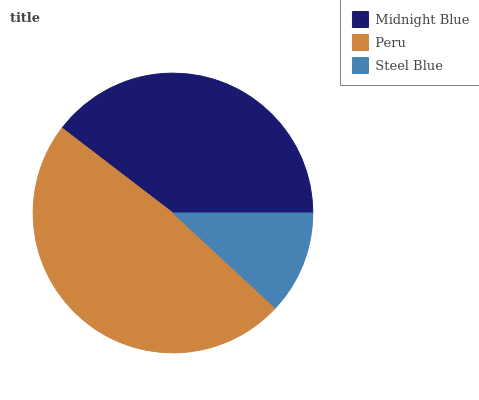Is Steel Blue the minimum?
Answer yes or no. Yes. Is Peru the maximum?
Answer yes or no. Yes. Is Peru the minimum?
Answer yes or no. No. Is Steel Blue the maximum?
Answer yes or no. No. Is Peru greater than Steel Blue?
Answer yes or no. Yes. Is Steel Blue less than Peru?
Answer yes or no. Yes. Is Steel Blue greater than Peru?
Answer yes or no. No. Is Peru less than Steel Blue?
Answer yes or no. No. Is Midnight Blue the high median?
Answer yes or no. Yes. Is Midnight Blue the low median?
Answer yes or no. Yes. Is Steel Blue the high median?
Answer yes or no. No. Is Peru the low median?
Answer yes or no. No. 